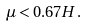<formula> <loc_0><loc_0><loc_500><loc_500>\mu < 0 . 6 7 H .</formula> 